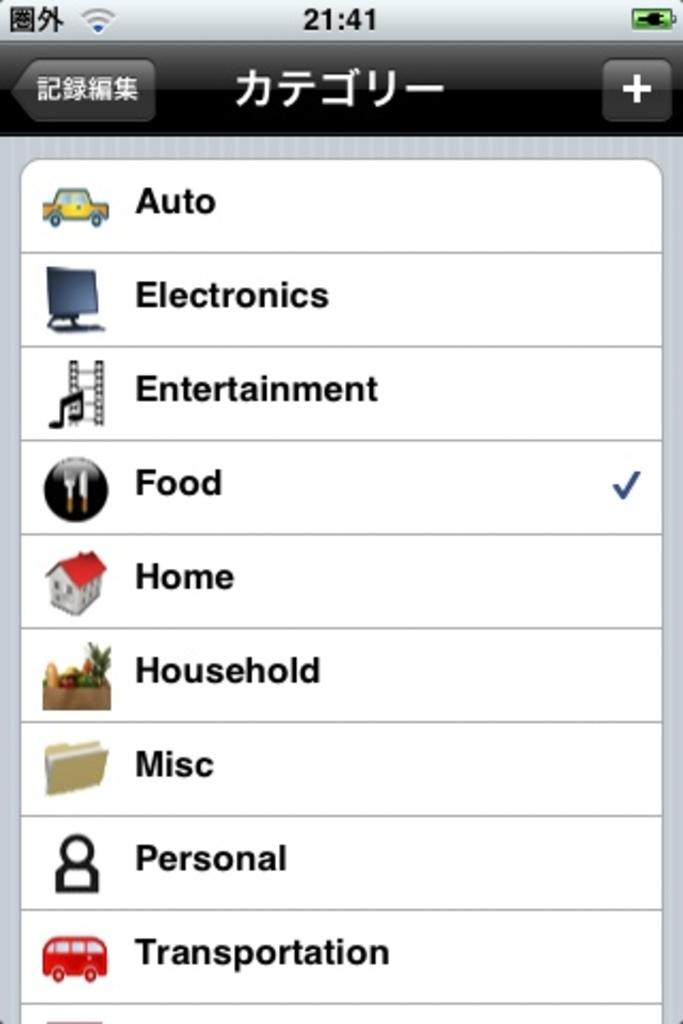What is the main object in the image? There is a screen in the image. What can be seen on the screen? The screen contains icons and text. What is the weather like in the image? The provided facts do not mention anything about the weather, so it cannot be determined from the image. 